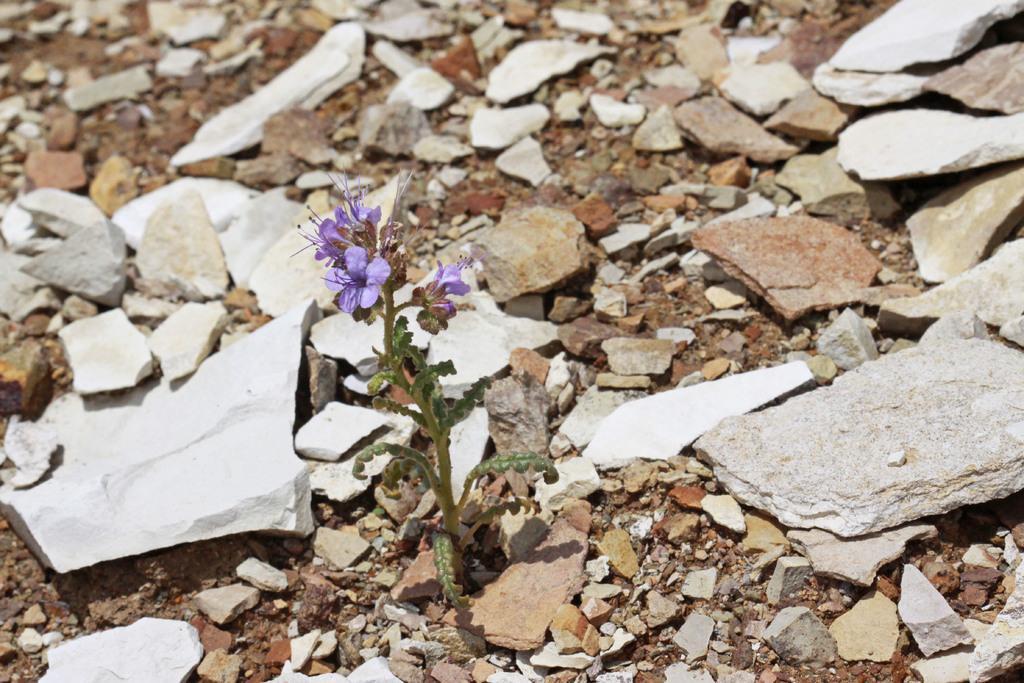In one or two sentences, can you explain what this image depicts? In the picture I can see some stones, there is a plant to which flowers are grown. 